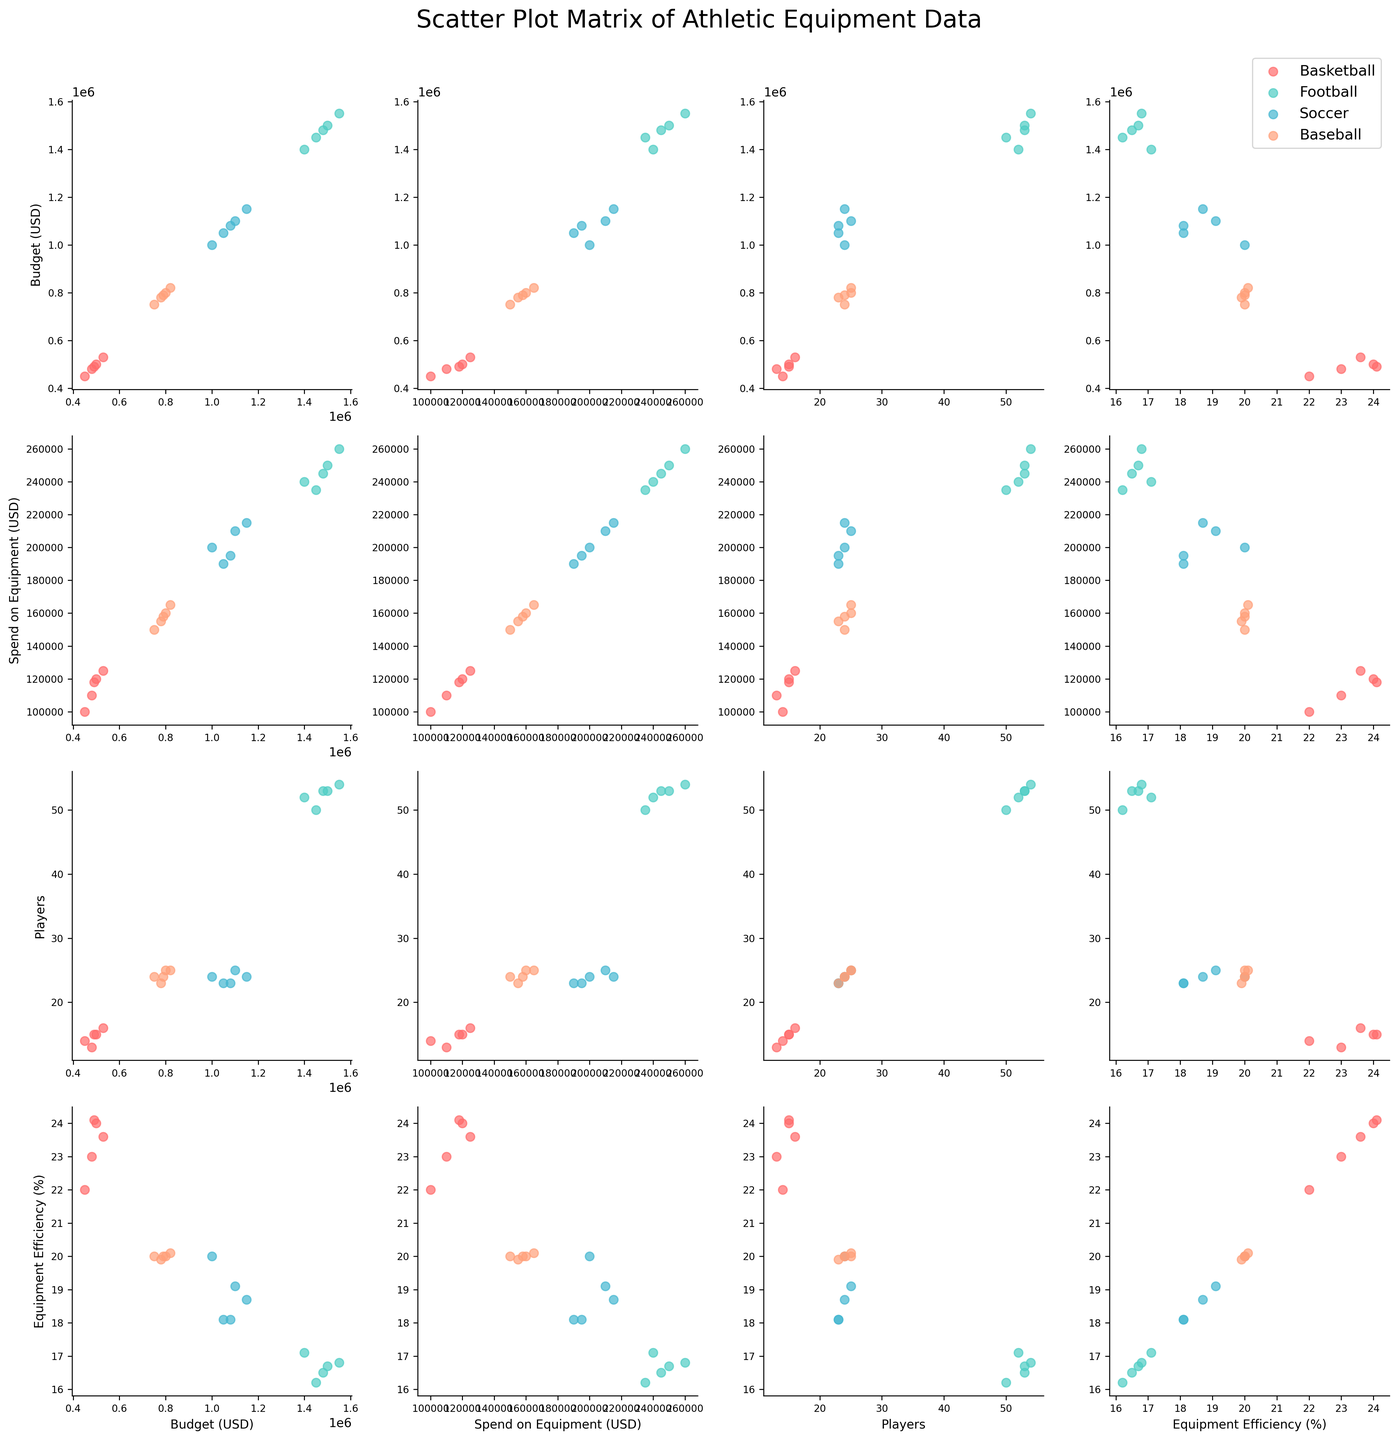Which sport has the lowest Equipment Efficiency (%) in the dataset? By looking at the scatter plot matrix, identify which group of colored points is positioned the lowest on the y-axis of the Equipment Efficiency (%) column.
Answer: Football Looking at 'Basketball' teams, how does the Spend on Equipment (USD) relate to the Equipment Efficiency (%)? Observe the scatter plots where these two columns intersect and identify the trend or pattern of basketball points (red).
Answer: Positive correlation Compare the average Budget (USD) for 'Baseball' and 'Basketball' teams. Which one is higher? Find 'Baseball' and 'Basketball' points in the Budget (USD) row, total their budgets and divide by the number of teams. Compare the two averages.
Answer: Basketball Which sport has the most consistent Equipment Efficiency (%) among its teams? In the 'Equipment Efficiency (%)' row, note the scatter plot where data points for a sport are clustered closely together indicating consistency.
Answer: Baseball Do larger teams (i.e., more players) tend to have higher Spend on Equipment (USD)? Look at the 'Players' vs 'Spend on Equipment (USD)' scatter plots and observe any trend among the data points of all sports combined.
Answer: Yes Are there any outlier teams in terms of Budget (USD) for 'Football'? Observe the Budget (USD) column and identify any football points (teal) that significantly deviate from the cluster.
Answer: No Is there a visible pattern between Spend on Equipment (USD) and Equipment Efficiency (%) for 'Soccer' teams? Look at the scatter plots intersecting these two columns and focus on the soccer points (blue). Discern any trend or pattern.
Answer: No clear pattern How does the Budget (USD) for 'Soccer' teams compare to 'Baseball' teams? Which one generally has higher budgets? Look at the 'Soccer' and 'Baseball' points in the Budget (USD) row and visually compare their positions on the x-axis.
Answer: Soccer Which sport has the highest variance in Budget (USD) when observing the scatter plot matrix? Identify the column for Budget (USD) and note which sport's points are spread out the most across the x-axis.
Answer: Football 